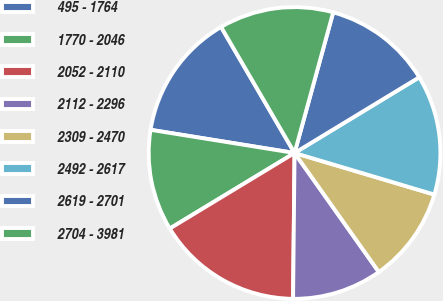<chart> <loc_0><loc_0><loc_500><loc_500><pie_chart><fcel>495 - 1764<fcel>1770 - 2046<fcel>2052 - 2110<fcel>2112 - 2296<fcel>2309 - 2470<fcel>2492 - 2617<fcel>2619 - 2701<fcel>2704 - 3981<nl><fcel>14.06%<fcel>11.21%<fcel>16.17%<fcel>9.97%<fcel>10.59%<fcel>13.29%<fcel>12.05%<fcel>12.67%<nl></chart> 